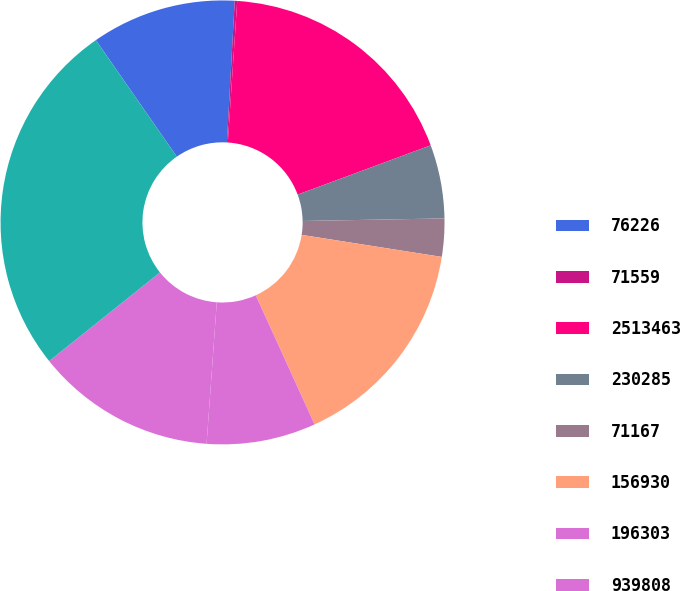Convert chart to OTSL. <chart><loc_0><loc_0><loc_500><loc_500><pie_chart><fcel>76226<fcel>71559<fcel>2513463<fcel>230285<fcel>71167<fcel>156930<fcel>196303<fcel>939808<fcel>4265915<nl><fcel>10.54%<fcel>0.18%<fcel>18.3%<fcel>5.36%<fcel>2.77%<fcel>15.71%<fcel>7.95%<fcel>13.12%<fcel>26.07%<nl></chart> 